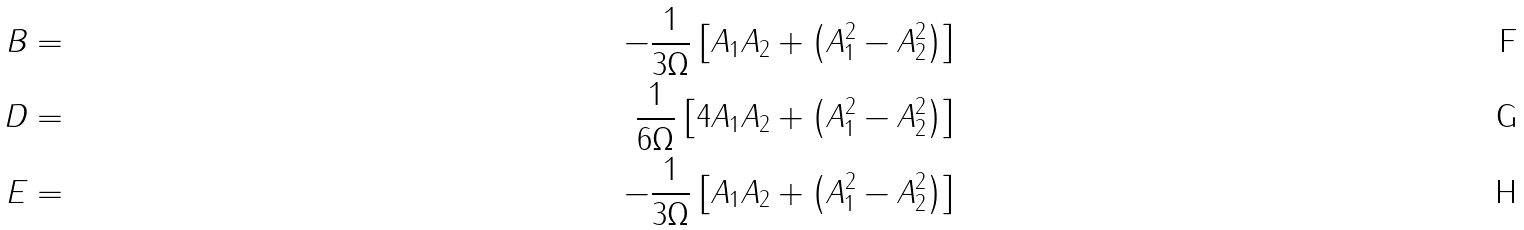Convert formula to latex. <formula><loc_0><loc_0><loc_500><loc_500>B & = & - \frac { 1 } { 3 \Omega } \left [ A _ { 1 } A _ { 2 } + \left ( A _ { 1 } ^ { 2 } - A _ { 2 } ^ { 2 } \right ) \right ] \\ D & = & \frac { 1 } { 6 \Omega } \left [ 4 A _ { 1 } A _ { 2 } + \left ( A _ { 1 } ^ { 2 } - A _ { 2 } ^ { 2 } \right ) \right ] \\ E & = & - \frac { 1 } { 3 \Omega } \left [ A _ { 1 } A _ { 2 } + \left ( A _ { 1 } ^ { 2 } - A _ { 2 } ^ { 2 } \right ) \right ]</formula> 